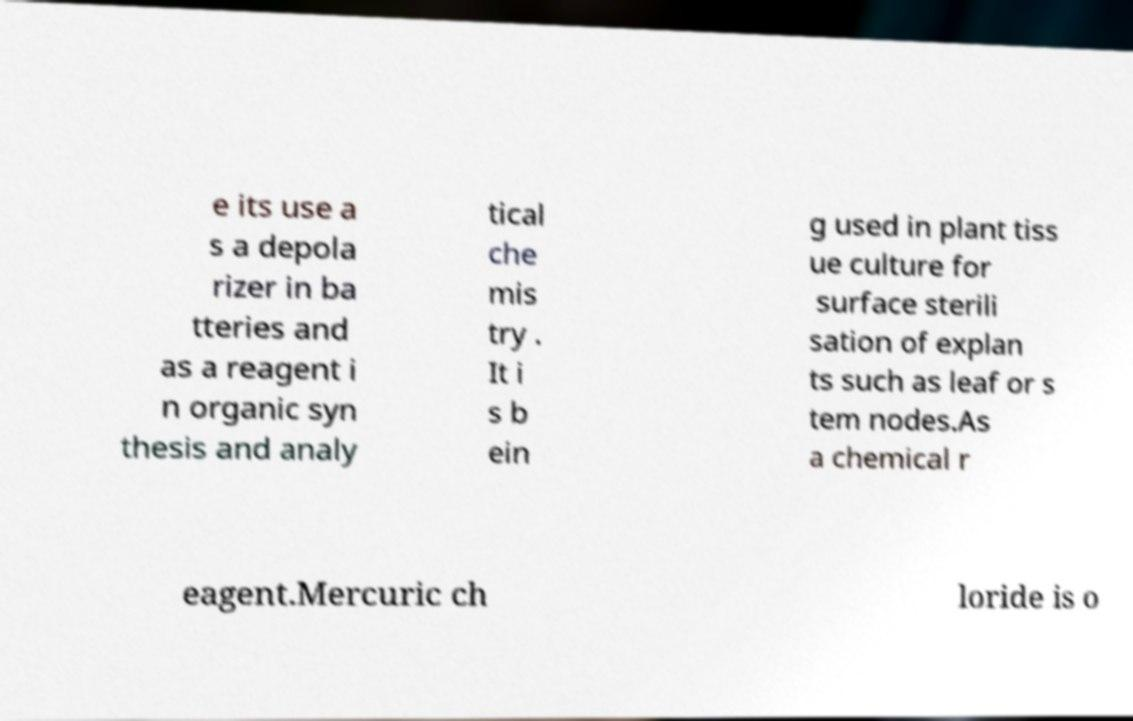I need the written content from this picture converted into text. Can you do that? e its use a s a depola rizer in ba tteries and as a reagent i n organic syn thesis and analy tical che mis try . It i s b ein g used in plant tiss ue culture for surface sterili sation of explan ts such as leaf or s tem nodes.As a chemical r eagent.Mercuric ch loride is o 